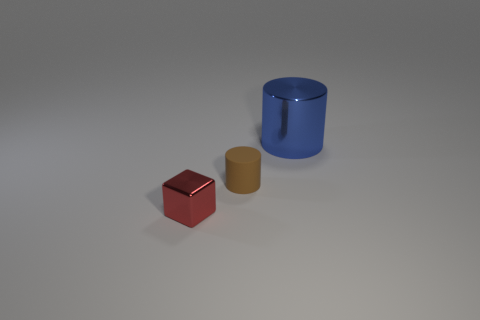Add 2 purple metallic cylinders. How many objects exist? 5 Subtract all cylinders. How many objects are left? 1 Subtract all brown matte cylinders. Subtract all small metal cubes. How many objects are left? 1 Add 3 small brown cylinders. How many small brown cylinders are left? 4 Add 2 small cylinders. How many small cylinders exist? 3 Subtract 0 yellow blocks. How many objects are left? 3 Subtract all green blocks. Subtract all cyan balls. How many blocks are left? 1 